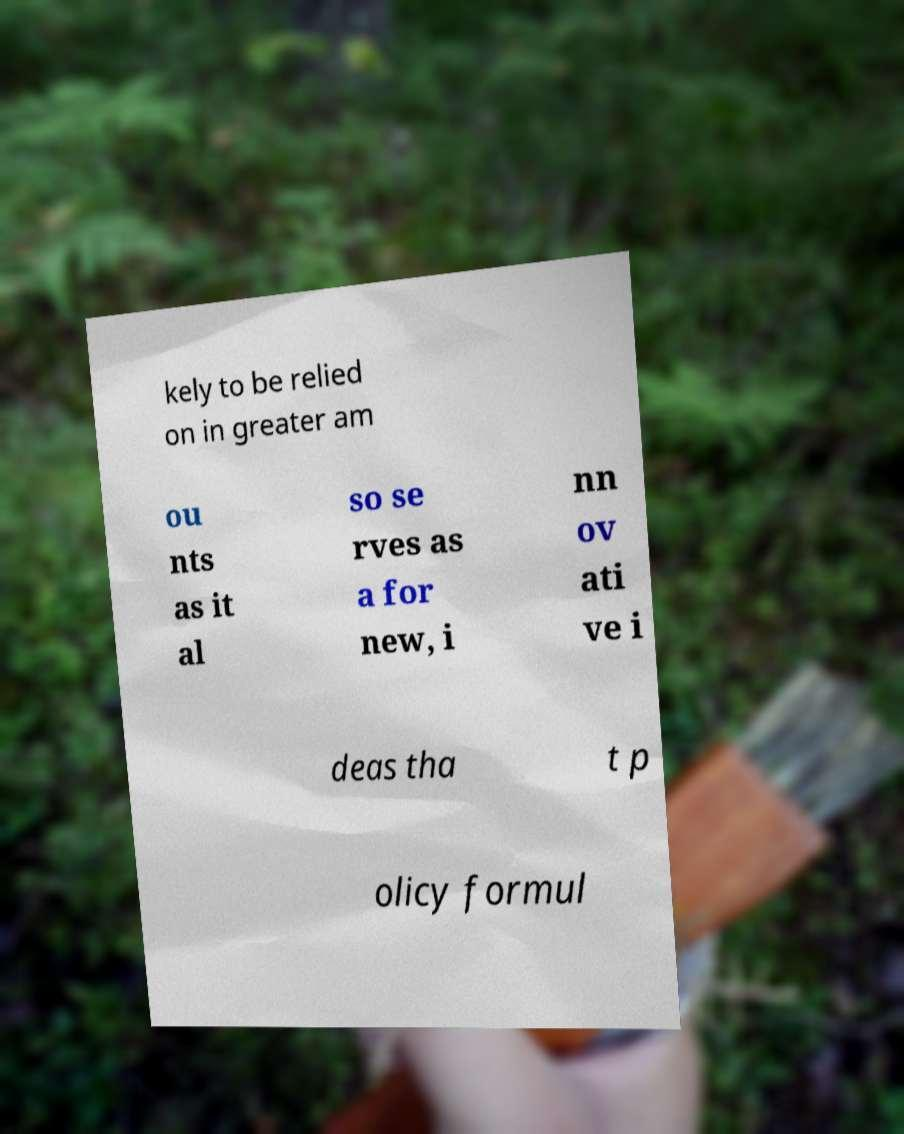For documentation purposes, I need the text within this image transcribed. Could you provide that? kely to be relied on in greater am ou nts as it al so se rves as a for new, i nn ov ati ve i deas tha t p olicy formul 